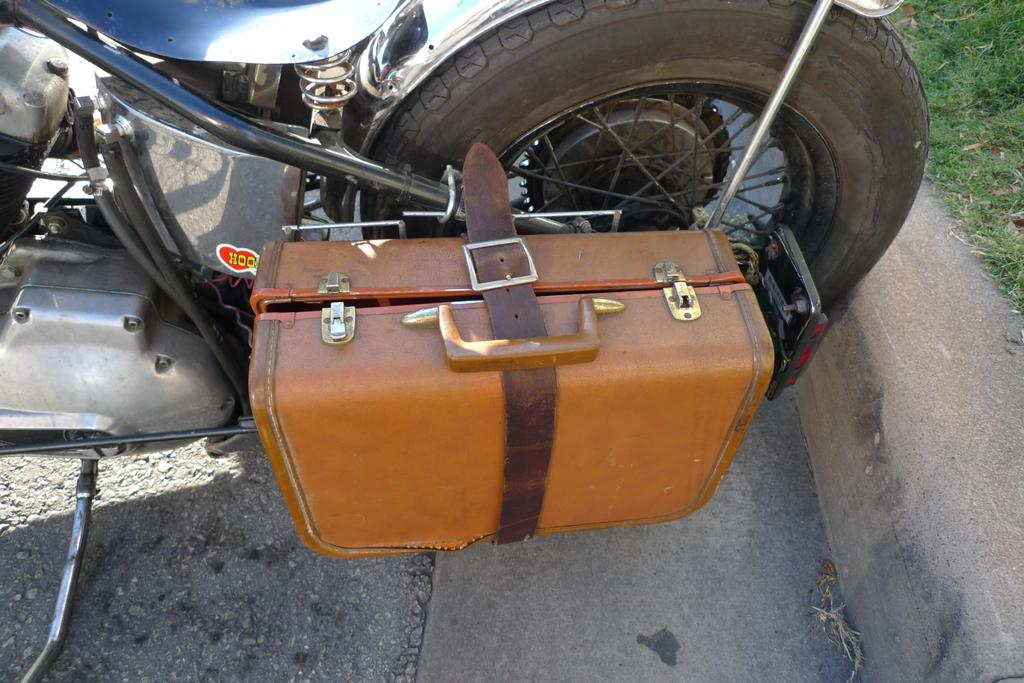What object can be seen in the image? There is a box in the image. What is located near the box? The box is beside a bike tyre. What type of humor can be seen in the image? There is no humor present in the image; it only features a box and a bike tyre. How many beds are visible in the image? There are no beds visible in the image. 